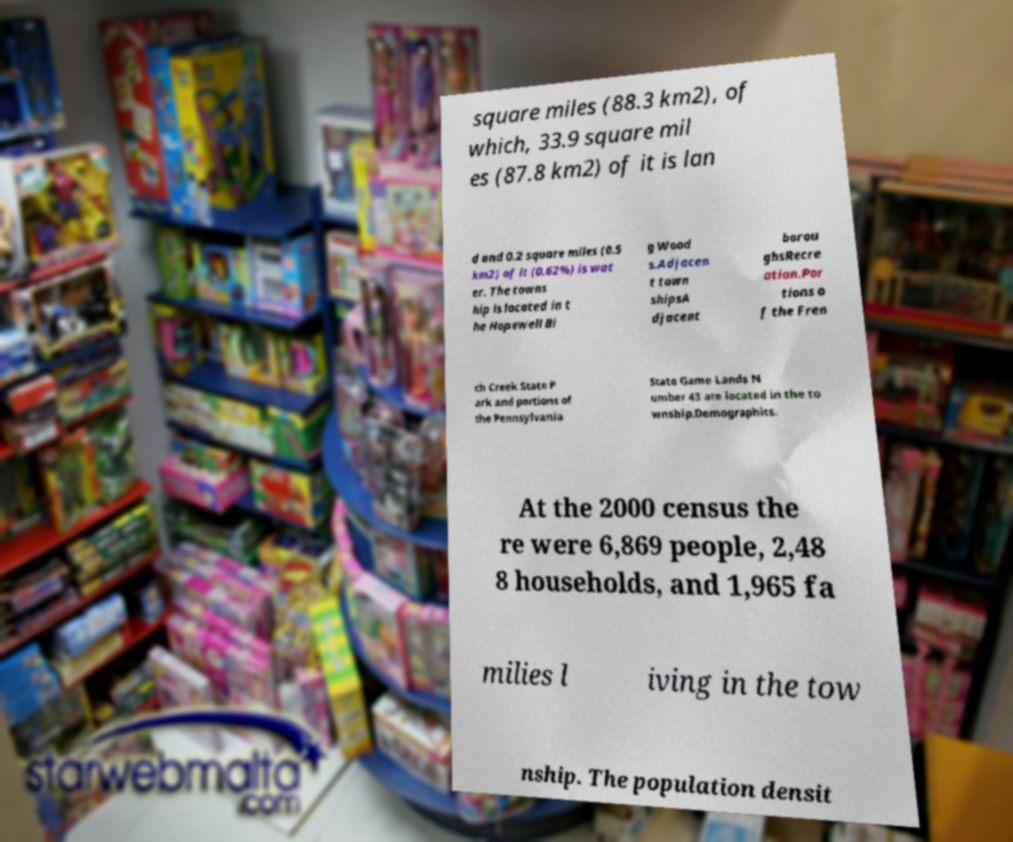Can you read and provide the text displayed in the image?This photo seems to have some interesting text. Can you extract and type it out for me? square miles (88.3 km2), of which, 33.9 square mil es (87.8 km2) of it is lan d and 0.2 square miles (0.5 km2) of it (0.62%) is wat er. The towns hip is located in t he Hopewell Bi g Wood s.Adjacen t town shipsA djacent borou ghsRecre ation.Por tions o f the Fren ch Creek State P ark and portions of the Pennsylvania State Game Lands N umber 43 are located in the to wnship.Demographics. At the 2000 census the re were 6,869 people, 2,48 8 households, and 1,965 fa milies l iving in the tow nship. The population densit 